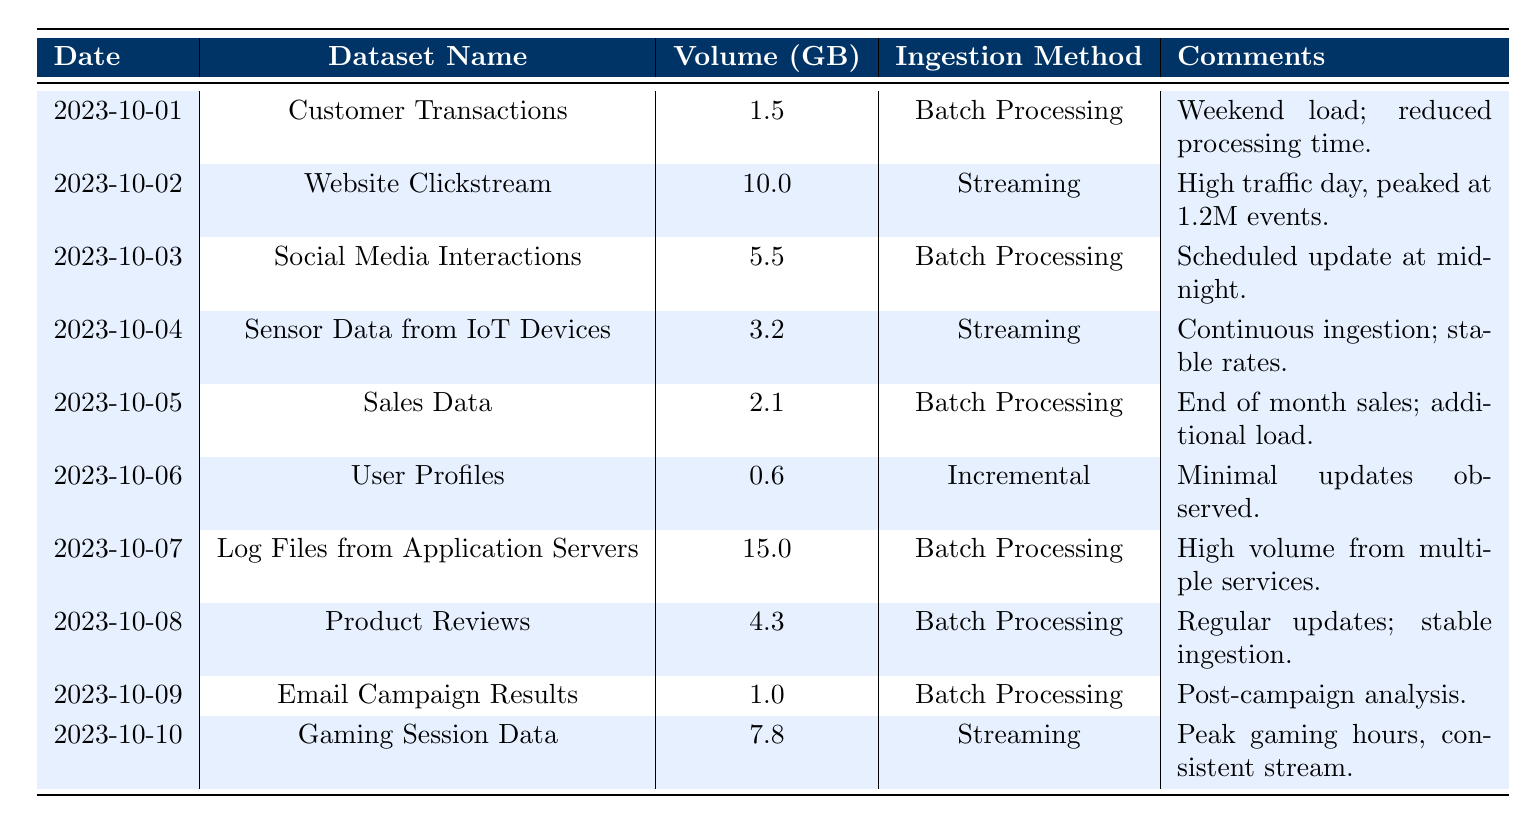What is the volume of data ingested for "Log Files from Application Servers"? The volume of data for "Log Files from Application Servers" is listed in the table under the "Volume (GB)" column for that dataset name, which shows a value of 15.0 GB.
Answer: 15.0 GB On which date was the "Website Clickstream" dataset ingested? The "Website Clickstream" dataset appears in the table under the "Dataset Name" column, and the corresponding date is shown in the "Date" column, which is 2023-10-02.
Answer: 2023-10-02 What is the total data volume ingested on the weekends (October 1 and 7)? The data volume for October 1 is 1.5 GB and for October 7 is 15.0 GB. Adding them together gives a total of 1.5 + 15.0 = 16.5 GB.
Answer: 16.5 GB Is the data ingestion method for "User Profiles" categorized as Batch Processing? The ingestion method for "User Profiles" is specified in the "Ingestion Method" column and is listed as "Incremental," not "Batch Processing," so the statement is false.
Answer: No Which dataset had the highest data volume ingested, and what was that volume? By inspecting the "Volume (GB)" column, the dataset with the highest volume is "Log Files from Application Servers," with a volume of 15.0 GB.
Answer: Log Files from Application Servers, 15.0 GB What percentage of the total data volume on October 10 was contributed by "Gaming Session Data"? First, we find the volume for October 10, which is 7.8 GB. The data volumes of all datasets ingested from October 1 to October 10 sum up to 46.0 GB. Therefore, (7.8 / 46.0) x 100 = approximately 16.96%.
Answer: Approximately 16.96% Was there any day when the ingestion volume exceeded 10 GB? By checking the "Volume (GB)" column, only the entry for "Website Clickstream" on October 2 shows a volume greater than 10 GB, which confirms the statement is true.
Answer: Yes What is the average data volume across all datasets listed in the table? To find the average, sum up all the volumes: 1.5 + 10.0 + 5.5 + 3.2 + 2.1 + 0.6 + 15.0 + 4.3 + 1.0 + 7.8 = 51.0 GB. Then divide by the number of datasets (10): 51.0 / 10 = 5.1 GB.
Answer: 5.1 GB What were the comments associated with the "Sales Data" ingestion? The comments for "Sales Data" can be found in the "Comments" column associated with that dataset name, which states "End of month sales; additional load."
Answer: End of month sales; additional load 